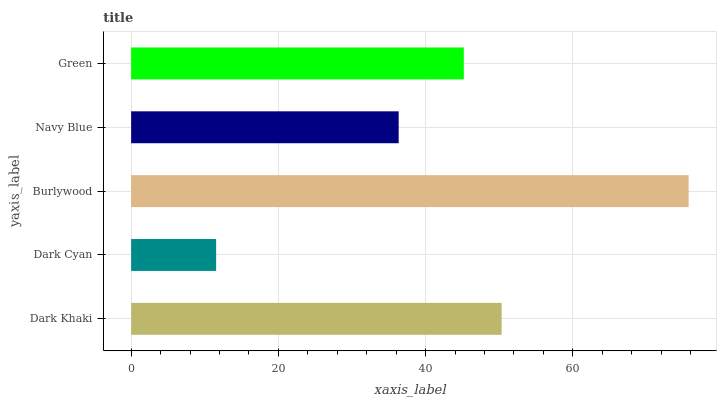Is Dark Cyan the minimum?
Answer yes or no. Yes. Is Burlywood the maximum?
Answer yes or no. Yes. Is Burlywood the minimum?
Answer yes or no. No. Is Dark Cyan the maximum?
Answer yes or no. No. Is Burlywood greater than Dark Cyan?
Answer yes or no. Yes. Is Dark Cyan less than Burlywood?
Answer yes or no. Yes. Is Dark Cyan greater than Burlywood?
Answer yes or no. No. Is Burlywood less than Dark Cyan?
Answer yes or no. No. Is Green the high median?
Answer yes or no. Yes. Is Green the low median?
Answer yes or no. Yes. Is Dark Khaki the high median?
Answer yes or no. No. Is Dark Khaki the low median?
Answer yes or no. No. 